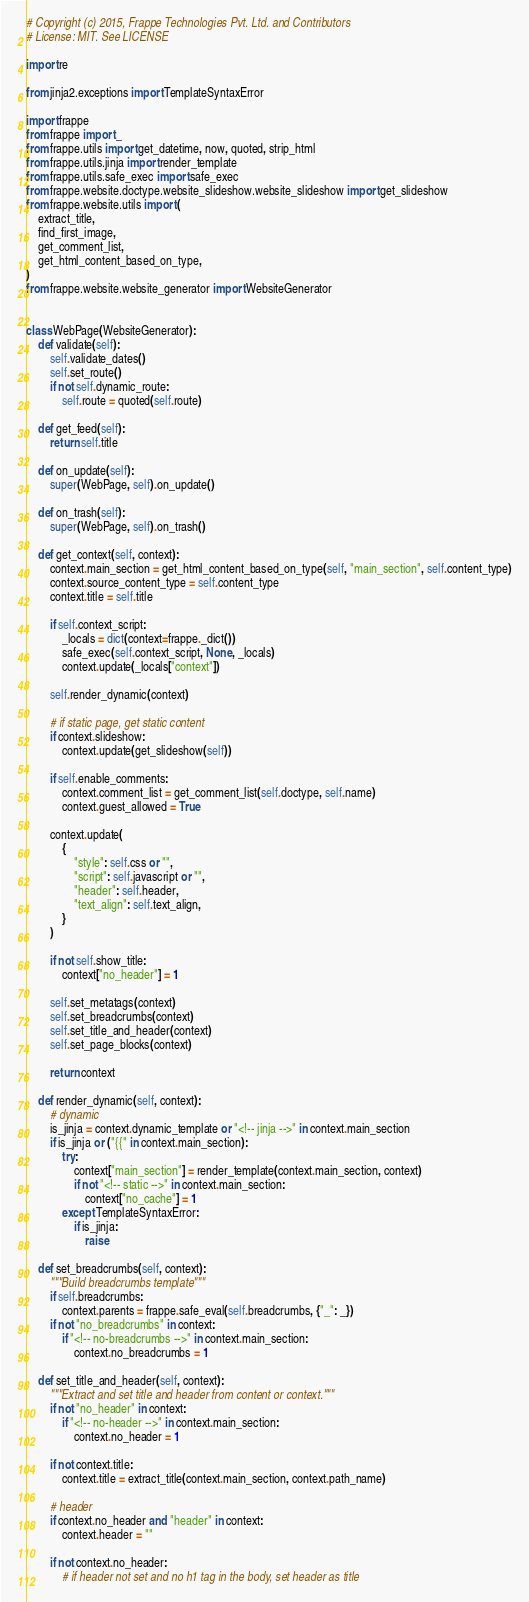Convert code to text. <code><loc_0><loc_0><loc_500><loc_500><_Python_># Copyright (c) 2015, Frappe Technologies Pvt. Ltd. and Contributors
# License: MIT. See LICENSE

import re

from jinja2.exceptions import TemplateSyntaxError

import frappe
from frappe import _
from frappe.utils import get_datetime, now, quoted, strip_html
from frappe.utils.jinja import render_template
from frappe.utils.safe_exec import safe_exec
from frappe.website.doctype.website_slideshow.website_slideshow import get_slideshow
from frappe.website.utils import (
	extract_title,
	find_first_image,
	get_comment_list,
	get_html_content_based_on_type,
)
from frappe.website.website_generator import WebsiteGenerator


class WebPage(WebsiteGenerator):
	def validate(self):
		self.validate_dates()
		self.set_route()
		if not self.dynamic_route:
			self.route = quoted(self.route)

	def get_feed(self):
		return self.title

	def on_update(self):
		super(WebPage, self).on_update()

	def on_trash(self):
		super(WebPage, self).on_trash()

	def get_context(self, context):
		context.main_section = get_html_content_based_on_type(self, "main_section", self.content_type)
		context.source_content_type = self.content_type
		context.title = self.title

		if self.context_script:
			_locals = dict(context=frappe._dict())
			safe_exec(self.context_script, None, _locals)
			context.update(_locals["context"])

		self.render_dynamic(context)

		# if static page, get static content
		if context.slideshow:
			context.update(get_slideshow(self))

		if self.enable_comments:
			context.comment_list = get_comment_list(self.doctype, self.name)
			context.guest_allowed = True

		context.update(
			{
				"style": self.css or "",
				"script": self.javascript or "",
				"header": self.header,
				"text_align": self.text_align,
			}
		)

		if not self.show_title:
			context["no_header"] = 1

		self.set_metatags(context)
		self.set_breadcrumbs(context)
		self.set_title_and_header(context)
		self.set_page_blocks(context)

		return context

	def render_dynamic(self, context):
		# dynamic
		is_jinja = context.dynamic_template or "<!-- jinja -->" in context.main_section
		if is_jinja or ("{{" in context.main_section):
			try:
				context["main_section"] = render_template(context.main_section, context)
				if not "<!-- static -->" in context.main_section:
					context["no_cache"] = 1
			except TemplateSyntaxError:
				if is_jinja:
					raise

	def set_breadcrumbs(self, context):
		"""Build breadcrumbs template"""
		if self.breadcrumbs:
			context.parents = frappe.safe_eval(self.breadcrumbs, {"_": _})
		if not "no_breadcrumbs" in context:
			if "<!-- no-breadcrumbs -->" in context.main_section:
				context.no_breadcrumbs = 1

	def set_title_and_header(self, context):
		"""Extract and set title and header from content or context."""
		if not "no_header" in context:
			if "<!-- no-header -->" in context.main_section:
				context.no_header = 1

		if not context.title:
			context.title = extract_title(context.main_section, context.path_name)

		# header
		if context.no_header and "header" in context:
			context.header = ""

		if not context.no_header:
			# if header not set and no h1 tag in the body, set header as title</code> 